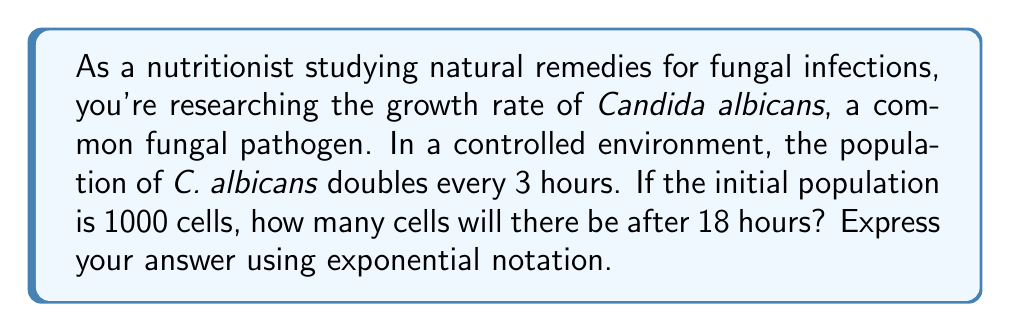Solve this math problem. Let's approach this step-by-step:

1) We can model this growth using an exponential function:

   $N(t) = N_0 \cdot 2^{t/3}$

   Where:
   $N(t)$ is the number of cells at time $t$
   $N_0$ is the initial number of cells
   $t$ is the time in hours
   3 is the doubling time in hours

2) We're given:
   $N_0 = 1000$ cells
   $t = 18$ hours

3) Let's substitute these values into our equation:

   $N(18) = 1000 \cdot 2^{18/3}$

4) Simplify the exponent:
   
   $N(18) = 1000 \cdot 2^6$

5) Calculate $2^6$:
   
   $2^6 = 64$

6) Multiply:
   
   $N(18) = 1000 \cdot 64 = 64000$

Therefore, after 18 hours, there will be 64,000 cells.
Answer: $6.4 \times 10^4$ cells 